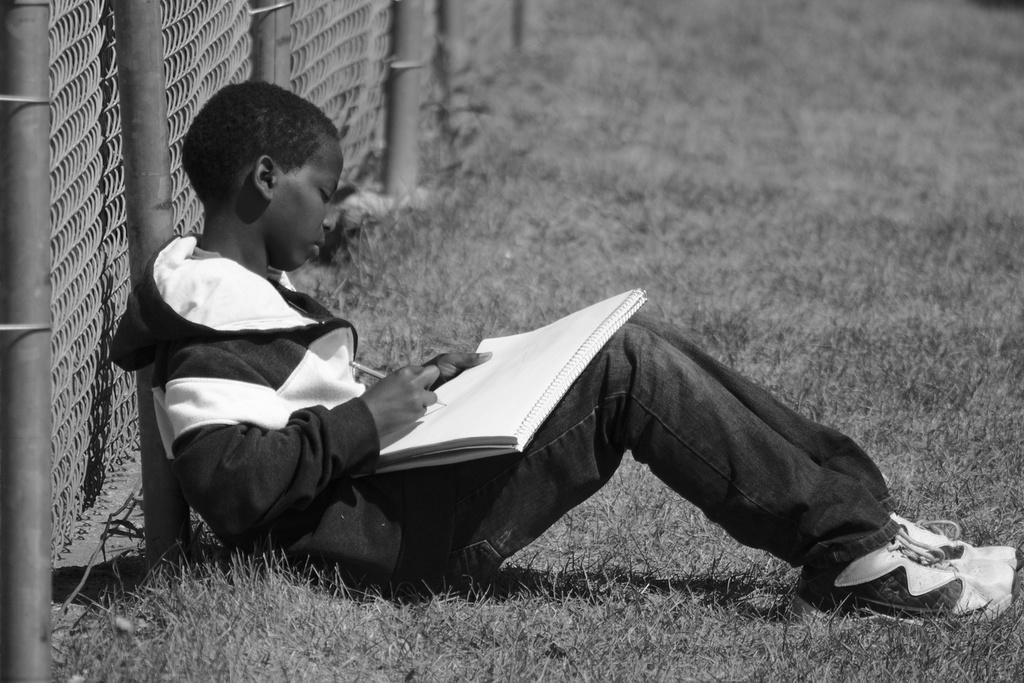What is the person in the image doing? The person is sitting in the image. What is the person holding in their hand? The person is holding a pencil and a book. What can be seen in the background of the image? There is a railing in the background of the image. How is the image presented in terms of color? The image is in black and white. What type of building is visible in the image? There is no building visible in the image; it only features a person sitting with a pencil and a book, and a railing in the background. How does the person's temper affect the image? The person's temper is not mentioned or depicted in the image, so it cannot be determined how it might affect the image. 